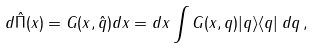<formula> <loc_0><loc_0><loc_500><loc_500>d \hat { \Pi } ( x ) = G ( x , \hat { q } ) d x = d x \int G ( x , q ) | q \rangle \langle q | \, d q \, ,</formula> 